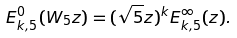<formula> <loc_0><loc_0><loc_500><loc_500>E _ { k , 5 } ^ { 0 } ( W _ { 5 } z ) = ( \sqrt { 5 } z ) ^ { k } E _ { k , 5 } ^ { \infty } ( z ) .</formula> 